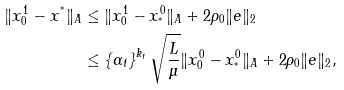<formula> <loc_0><loc_0><loc_500><loc_500>\| x _ { 0 } ^ { 1 } - x ^ { ^ { * } } \| _ { A } & \leq \| x _ { 0 } ^ { 1 } - x _ { ^ { * } } ^ { 0 } \| _ { A } + 2 \rho _ { 0 } \| e \| _ { 2 } \\ & \leq \left \{ \alpha _ { t } \right \} ^ { k _ { t } } \sqrt { \frac { L } { \mu } } \| x _ { 0 } ^ { 0 } - x _ { ^ { * } } ^ { 0 } \| _ { A } + 2 \rho _ { 0 } \| e \| _ { 2 } ,</formula> 